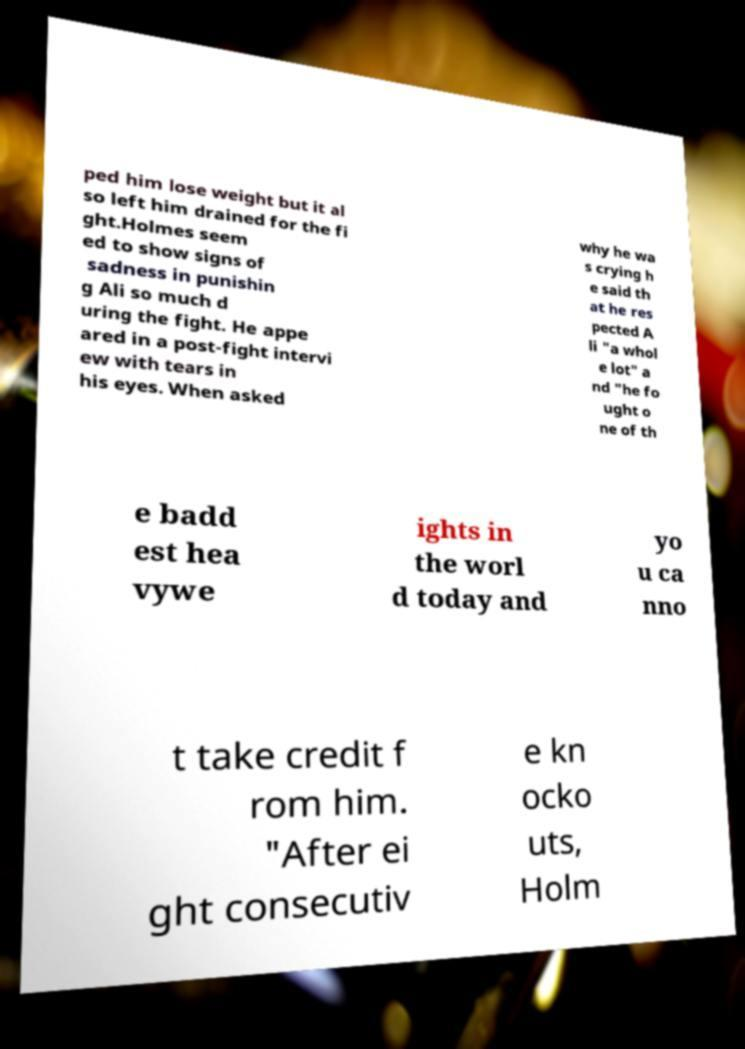Can you read and provide the text displayed in the image?This photo seems to have some interesting text. Can you extract and type it out for me? ped him lose weight but it al so left him drained for the fi ght.Holmes seem ed to show signs of sadness in punishin g Ali so much d uring the fight. He appe ared in a post-fight intervi ew with tears in his eyes. When asked why he wa s crying h e said th at he res pected A li "a whol e lot" a nd "he fo ught o ne of th e badd est hea vywe ights in the worl d today and yo u ca nno t take credit f rom him. "After ei ght consecutiv e kn ocko uts, Holm 